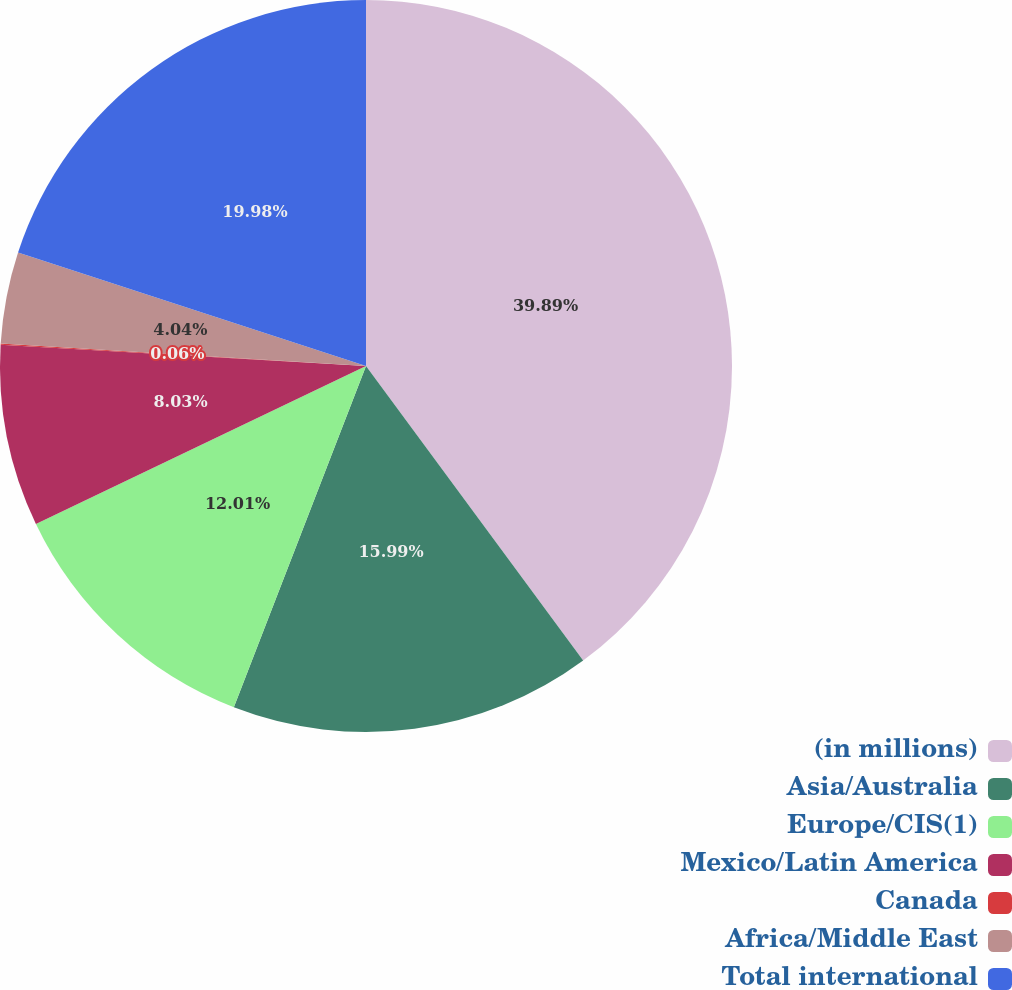Convert chart. <chart><loc_0><loc_0><loc_500><loc_500><pie_chart><fcel>(in millions)<fcel>Asia/Australia<fcel>Europe/CIS(1)<fcel>Mexico/Latin America<fcel>Canada<fcel>Africa/Middle East<fcel>Total international<nl><fcel>39.89%<fcel>15.99%<fcel>12.01%<fcel>8.03%<fcel>0.06%<fcel>4.04%<fcel>19.98%<nl></chart> 